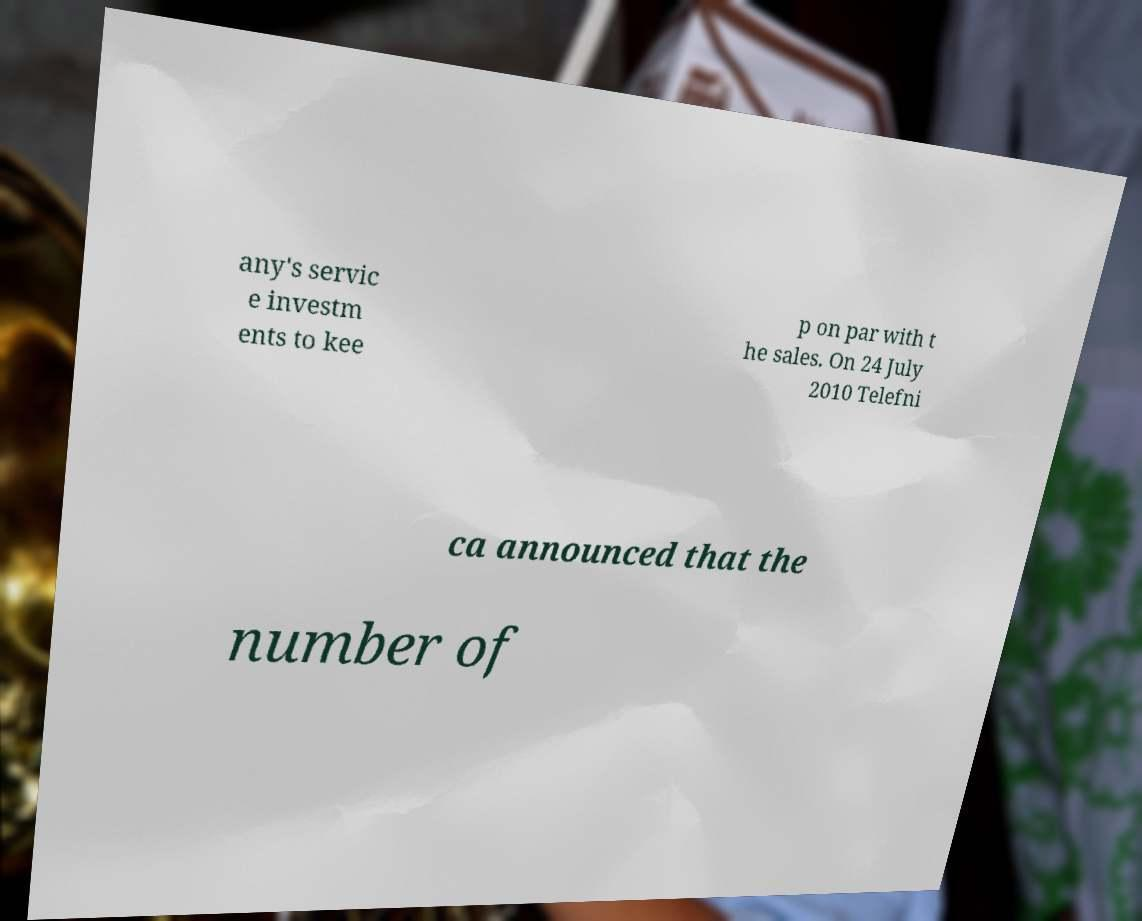I need the written content from this picture converted into text. Can you do that? any's servic e investm ents to kee p on par with t he sales. On 24 July 2010 Telefni ca announced that the number of 